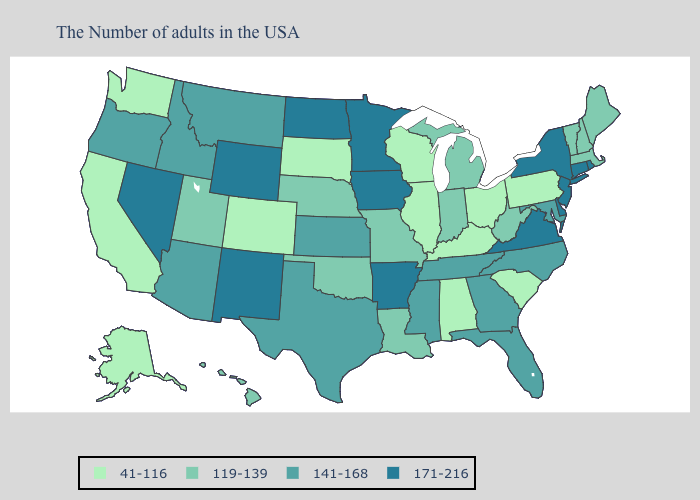Does the map have missing data?
Concise answer only. No. What is the lowest value in states that border Florida?
Quick response, please. 41-116. Name the states that have a value in the range 41-116?
Write a very short answer. Pennsylvania, South Carolina, Ohio, Kentucky, Alabama, Wisconsin, Illinois, South Dakota, Colorado, California, Washington, Alaska. What is the lowest value in states that border Idaho?
Give a very brief answer. 41-116. Among the states that border Indiana , which have the highest value?
Keep it brief. Michigan. Name the states that have a value in the range 171-216?
Short answer required. Rhode Island, Connecticut, New York, New Jersey, Delaware, Virginia, Arkansas, Minnesota, Iowa, North Dakota, Wyoming, New Mexico, Nevada. Name the states that have a value in the range 141-168?
Be succinct. Maryland, North Carolina, Florida, Georgia, Tennessee, Mississippi, Kansas, Texas, Montana, Arizona, Idaho, Oregon. What is the highest value in the Northeast ?
Be succinct. 171-216. Name the states that have a value in the range 41-116?
Keep it brief. Pennsylvania, South Carolina, Ohio, Kentucky, Alabama, Wisconsin, Illinois, South Dakota, Colorado, California, Washington, Alaska. How many symbols are there in the legend?
Give a very brief answer. 4. Which states hav the highest value in the MidWest?
Answer briefly. Minnesota, Iowa, North Dakota. Among the states that border New York , does Massachusetts have the highest value?
Give a very brief answer. No. What is the lowest value in the USA?
Be succinct. 41-116. Name the states that have a value in the range 171-216?
Give a very brief answer. Rhode Island, Connecticut, New York, New Jersey, Delaware, Virginia, Arkansas, Minnesota, Iowa, North Dakota, Wyoming, New Mexico, Nevada. 